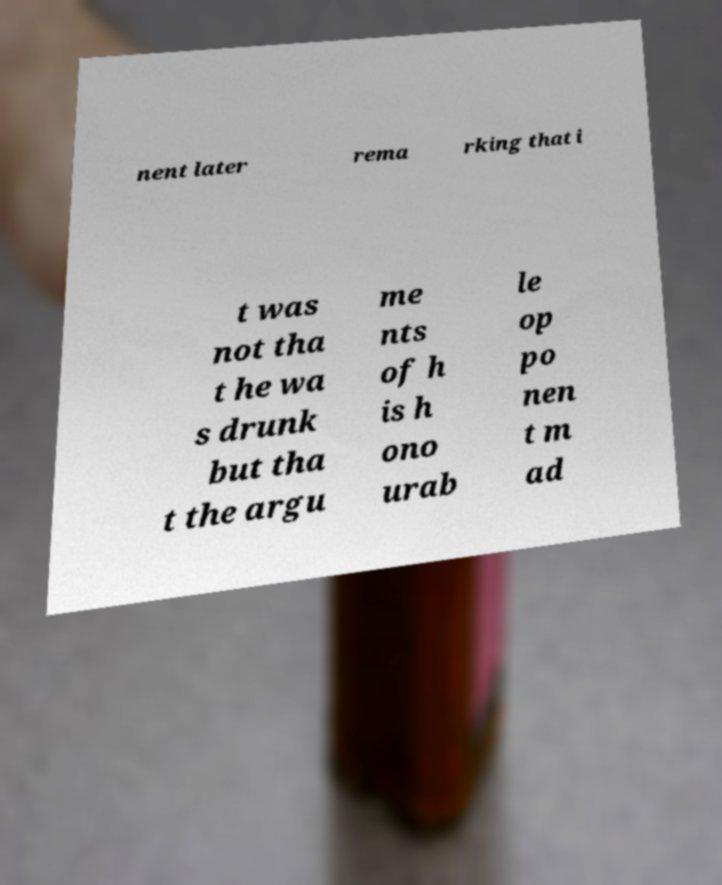There's text embedded in this image that I need extracted. Can you transcribe it verbatim? nent later rema rking that i t was not tha t he wa s drunk but tha t the argu me nts of h is h ono urab le op po nen t m ad 